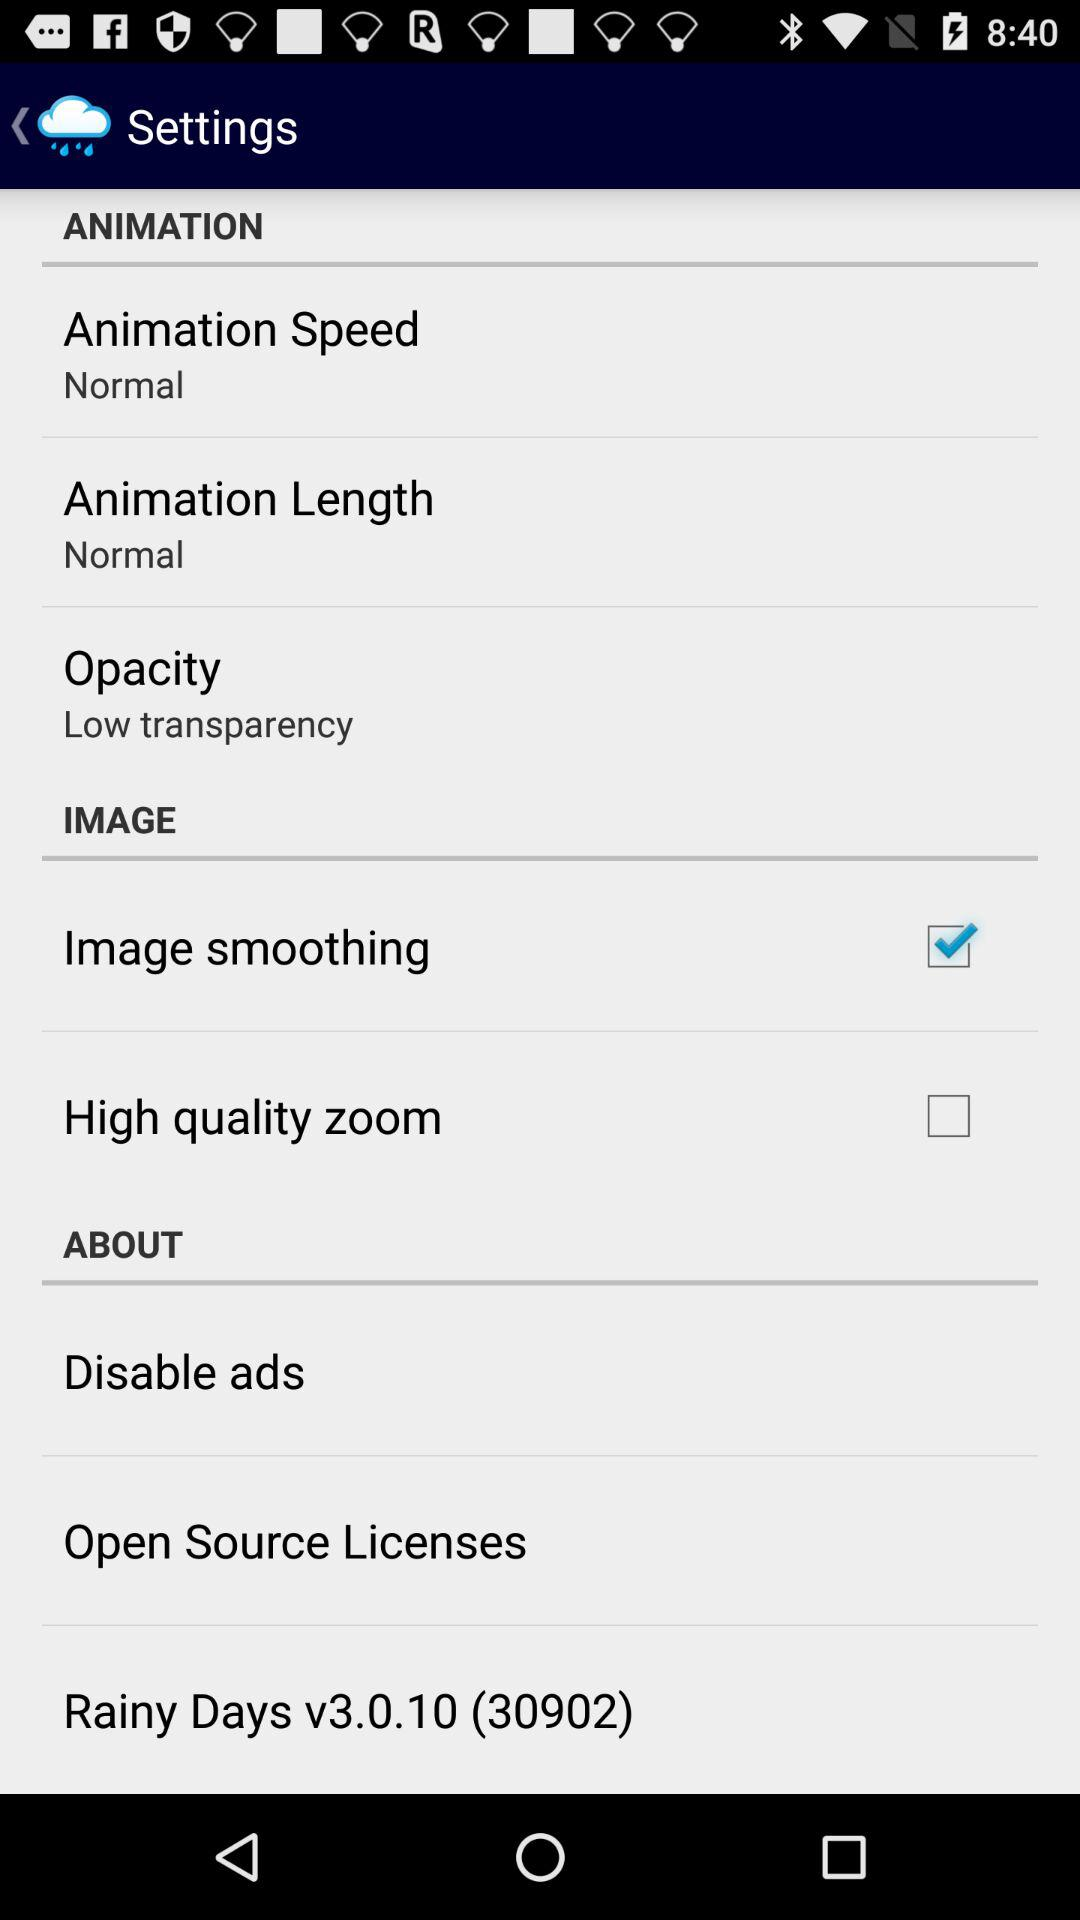Is "High quality zoom" checked or unchecked? "High quality zoom" is unchecked. 